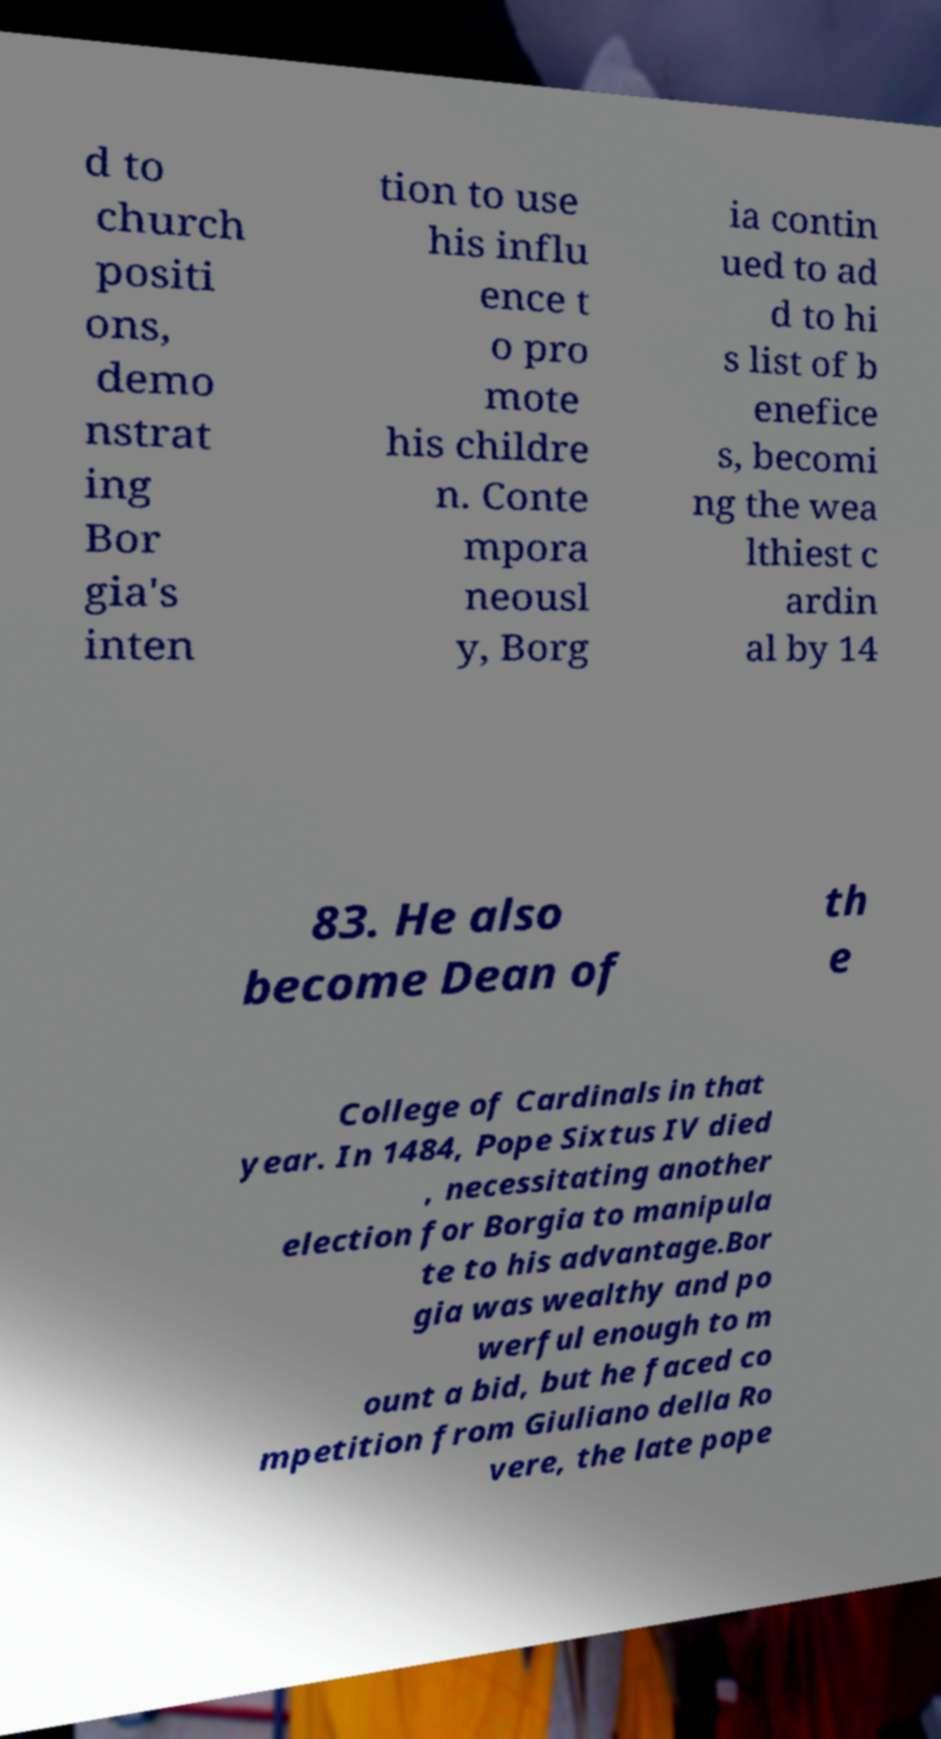There's text embedded in this image that I need extracted. Can you transcribe it verbatim? d to church positi ons, demo nstrat ing Bor gia's inten tion to use his influ ence t o pro mote his childre n. Conte mpora neousl y, Borg ia contin ued to ad d to hi s list of b enefice s, becomi ng the wea lthiest c ardin al by 14 83. He also become Dean of th e College of Cardinals in that year. In 1484, Pope Sixtus IV died , necessitating another election for Borgia to manipula te to his advantage.Bor gia was wealthy and po werful enough to m ount a bid, but he faced co mpetition from Giuliano della Ro vere, the late pope 